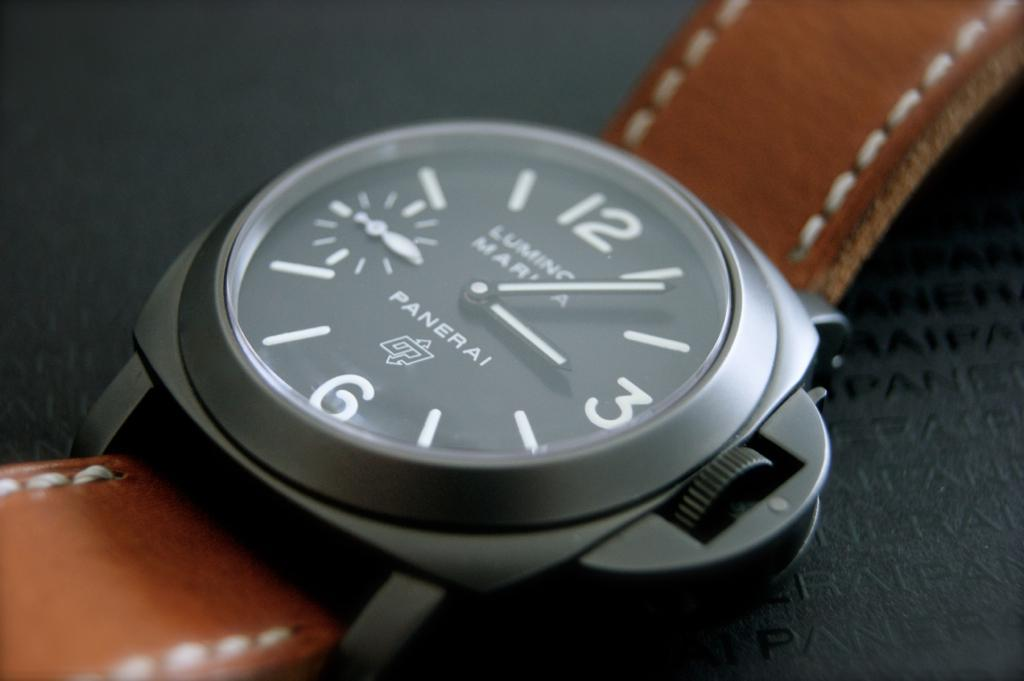Provide a one-sentence caption for the provided image. A Panerai watch with a brown leather strap on it. 